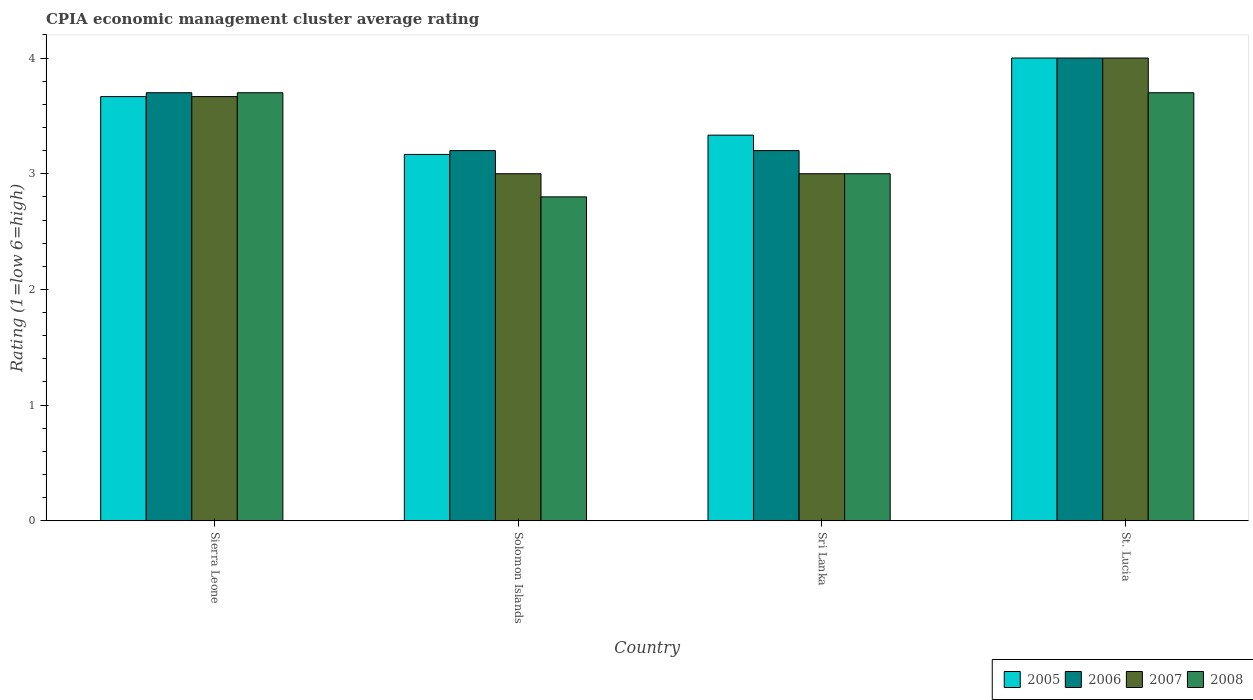How many groups of bars are there?
Your answer should be compact. 4. Are the number of bars on each tick of the X-axis equal?
Offer a terse response. Yes. How many bars are there on the 1st tick from the left?
Offer a very short reply. 4. What is the label of the 1st group of bars from the left?
Keep it short and to the point. Sierra Leone. In how many cases, is the number of bars for a given country not equal to the number of legend labels?
Your response must be concise. 0. What is the CPIA rating in 2005 in Sierra Leone?
Provide a short and direct response. 3.67. Across all countries, what is the minimum CPIA rating in 2006?
Your answer should be compact. 3.2. In which country was the CPIA rating in 2008 maximum?
Provide a succinct answer. Sierra Leone. In which country was the CPIA rating in 2006 minimum?
Keep it short and to the point. Solomon Islands. What is the total CPIA rating in 2007 in the graph?
Offer a very short reply. 13.67. What is the difference between the CPIA rating in 2005 in Solomon Islands and that in St. Lucia?
Your answer should be very brief. -0.83. What is the difference between the CPIA rating in 2007 in Solomon Islands and the CPIA rating in 2008 in Sierra Leone?
Offer a terse response. -0.7. What is the average CPIA rating in 2005 per country?
Your response must be concise. 3.54. In how many countries, is the CPIA rating in 2006 greater than 3.6?
Your answer should be compact. 2. What is the ratio of the CPIA rating in 2008 in Solomon Islands to that in St. Lucia?
Provide a short and direct response. 0.76. Is the CPIA rating in 2006 in Sri Lanka less than that in St. Lucia?
Your response must be concise. Yes. Is the difference between the CPIA rating in 2007 in Solomon Islands and Sri Lanka greater than the difference between the CPIA rating in 2006 in Solomon Islands and Sri Lanka?
Make the answer very short. No. What is the difference between the highest and the second highest CPIA rating in 2006?
Give a very brief answer. -0.5. Is the sum of the CPIA rating in 2008 in Sierra Leone and St. Lucia greater than the maximum CPIA rating in 2005 across all countries?
Make the answer very short. Yes. Is it the case that in every country, the sum of the CPIA rating in 2007 and CPIA rating in 2005 is greater than the sum of CPIA rating in 2006 and CPIA rating in 2008?
Provide a succinct answer. No. What does the 2nd bar from the left in St. Lucia represents?
Keep it short and to the point. 2006. Is it the case that in every country, the sum of the CPIA rating in 2005 and CPIA rating in 2008 is greater than the CPIA rating in 2006?
Ensure brevity in your answer.  Yes. How many bars are there?
Your response must be concise. 16. Are all the bars in the graph horizontal?
Ensure brevity in your answer.  No. How many countries are there in the graph?
Offer a very short reply. 4. Are the values on the major ticks of Y-axis written in scientific E-notation?
Offer a very short reply. No. Does the graph contain any zero values?
Offer a terse response. No. Where does the legend appear in the graph?
Give a very brief answer. Bottom right. How many legend labels are there?
Provide a short and direct response. 4. What is the title of the graph?
Give a very brief answer. CPIA economic management cluster average rating. Does "1991" appear as one of the legend labels in the graph?
Provide a short and direct response. No. What is the label or title of the Y-axis?
Make the answer very short. Rating (1=low 6=high). What is the Rating (1=low 6=high) in 2005 in Sierra Leone?
Your answer should be compact. 3.67. What is the Rating (1=low 6=high) of 2007 in Sierra Leone?
Your response must be concise. 3.67. What is the Rating (1=low 6=high) of 2008 in Sierra Leone?
Make the answer very short. 3.7. What is the Rating (1=low 6=high) in 2005 in Solomon Islands?
Offer a terse response. 3.17. What is the Rating (1=low 6=high) in 2005 in Sri Lanka?
Keep it short and to the point. 3.33. What is the Rating (1=low 6=high) of 2006 in Sri Lanka?
Keep it short and to the point. 3.2. What is the Rating (1=low 6=high) of 2007 in Sri Lanka?
Make the answer very short. 3. What is the Rating (1=low 6=high) in 2008 in Sri Lanka?
Your response must be concise. 3. What is the Rating (1=low 6=high) in 2005 in St. Lucia?
Offer a terse response. 4. What is the Rating (1=low 6=high) of 2006 in St. Lucia?
Offer a very short reply. 4. What is the Rating (1=low 6=high) of 2007 in St. Lucia?
Your answer should be very brief. 4. What is the Rating (1=low 6=high) in 2008 in St. Lucia?
Your answer should be compact. 3.7. Across all countries, what is the maximum Rating (1=low 6=high) in 2005?
Make the answer very short. 4. Across all countries, what is the maximum Rating (1=low 6=high) of 2006?
Keep it short and to the point. 4. Across all countries, what is the maximum Rating (1=low 6=high) of 2007?
Keep it short and to the point. 4. Across all countries, what is the minimum Rating (1=low 6=high) in 2005?
Offer a terse response. 3.17. Across all countries, what is the minimum Rating (1=low 6=high) of 2008?
Offer a very short reply. 2.8. What is the total Rating (1=low 6=high) in 2005 in the graph?
Keep it short and to the point. 14.17. What is the total Rating (1=low 6=high) in 2007 in the graph?
Your response must be concise. 13.67. What is the difference between the Rating (1=low 6=high) of 2005 in Sierra Leone and that in Solomon Islands?
Make the answer very short. 0.5. What is the difference between the Rating (1=low 6=high) of 2006 in Sierra Leone and that in Solomon Islands?
Your response must be concise. 0.5. What is the difference between the Rating (1=low 6=high) in 2007 in Sierra Leone and that in Solomon Islands?
Your response must be concise. 0.67. What is the difference between the Rating (1=low 6=high) in 2008 in Sierra Leone and that in Solomon Islands?
Provide a succinct answer. 0.9. What is the difference between the Rating (1=low 6=high) of 2006 in Sierra Leone and that in Sri Lanka?
Your answer should be compact. 0.5. What is the difference between the Rating (1=low 6=high) in 2008 in Sierra Leone and that in Sri Lanka?
Provide a short and direct response. 0.7. What is the difference between the Rating (1=low 6=high) in 2007 in Sierra Leone and that in St. Lucia?
Offer a very short reply. -0.33. What is the difference between the Rating (1=low 6=high) of 2005 in Solomon Islands and that in Sri Lanka?
Your response must be concise. -0.17. What is the difference between the Rating (1=low 6=high) of 2006 in Solomon Islands and that in Sri Lanka?
Ensure brevity in your answer.  0. What is the difference between the Rating (1=low 6=high) in 2007 in Solomon Islands and that in Sri Lanka?
Give a very brief answer. 0. What is the difference between the Rating (1=low 6=high) in 2008 in Solomon Islands and that in Sri Lanka?
Offer a very short reply. -0.2. What is the difference between the Rating (1=low 6=high) of 2006 in Solomon Islands and that in St. Lucia?
Your answer should be compact. -0.8. What is the difference between the Rating (1=low 6=high) of 2007 in Solomon Islands and that in St. Lucia?
Provide a succinct answer. -1. What is the difference between the Rating (1=low 6=high) in 2008 in Solomon Islands and that in St. Lucia?
Offer a very short reply. -0.9. What is the difference between the Rating (1=low 6=high) in 2005 in Sri Lanka and that in St. Lucia?
Provide a succinct answer. -0.67. What is the difference between the Rating (1=low 6=high) of 2006 in Sri Lanka and that in St. Lucia?
Offer a terse response. -0.8. What is the difference between the Rating (1=low 6=high) of 2007 in Sri Lanka and that in St. Lucia?
Keep it short and to the point. -1. What is the difference between the Rating (1=low 6=high) in 2008 in Sri Lanka and that in St. Lucia?
Offer a terse response. -0.7. What is the difference between the Rating (1=low 6=high) of 2005 in Sierra Leone and the Rating (1=low 6=high) of 2006 in Solomon Islands?
Make the answer very short. 0.47. What is the difference between the Rating (1=low 6=high) of 2005 in Sierra Leone and the Rating (1=low 6=high) of 2008 in Solomon Islands?
Your response must be concise. 0.87. What is the difference between the Rating (1=low 6=high) in 2006 in Sierra Leone and the Rating (1=low 6=high) in 2007 in Solomon Islands?
Provide a short and direct response. 0.7. What is the difference between the Rating (1=low 6=high) in 2006 in Sierra Leone and the Rating (1=low 6=high) in 2008 in Solomon Islands?
Offer a terse response. 0.9. What is the difference between the Rating (1=low 6=high) of 2007 in Sierra Leone and the Rating (1=low 6=high) of 2008 in Solomon Islands?
Your answer should be compact. 0.87. What is the difference between the Rating (1=low 6=high) of 2005 in Sierra Leone and the Rating (1=low 6=high) of 2006 in Sri Lanka?
Provide a short and direct response. 0.47. What is the difference between the Rating (1=low 6=high) in 2005 in Sierra Leone and the Rating (1=low 6=high) in 2007 in Sri Lanka?
Provide a succinct answer. 0.67. What is the difference between the Rating (1=low 6=high) of 2006 in Sierra Leone and the Rating (1=low 6=high) of 2007 in Sri Lanka?
Your answer should be compact. 0.7. What is the difference between the Rating (1=low 6=high) in 2007 in Sierra Leone and the Rating (1=low 6=high) in 2008 in Sri Lanka?
Offer a very short reply. 0.67. What is the difference between the Rating (1=low 6=high) in 2005 in Sierra Leone and the Rating (1=low 6=high) in 2007 in St. Lucia?
Ensure brevity in your answer.  -0.33. What is the difference between the Rating (1=low 6=high) of 2005 in Sierra Leone and the Rating (1=low 6=high) of 2008 in St. Lucia?
Give a very brief answer. -0.03. What is the difference between the Rating (1=low 6=high) of 2006 in Sierra Leone and the Rating (1=low 6=high) of 2008 in St. Lucia?
Give a very brief answer. 0. What is the difference between the Rating (1=low 6=high) in 2007 in Sierra Leone and the Rating (1=low 6=high) in 2008 in St. Lucia?
Keep it short and to the point. -0.03. What is the difference between the Rating (1=low 6=high) of 2005 in Solomon Islands and the Rating (1=low 6=high) of 2006 in Sri Lanka?
Keep it short and to the point. -0.03. What is the difference between the Rating (1=low 6=high) of 2005 in Solomon Islands and the Rating (1=low 6=high) of 2007 in Sri Lanka?
Provide a succinct answer. 0.17. What is the difference between the Rating (1=low 6=high) of 2005 in Solomon Islands and the Rating (1=low 6=high) of 2008 in Sri Lanka?
Your answer should be very brief. 0.17. What is the difference between the Rating (1=low 6=high) in 2007 in Solomon Islands and the Rating (1=low 6=high) in 2008 in Sri Lanka?
Keep it short and to the point. 0. What is the difference between the Rating (1=low 6=high) in 2005 in Solomon Islands and the Rating (1=low 6=high) in 2006 in St. Lucia?
Your answer should be compact. -0.83. What is the difference between the Rating (1=low 6=high) of 2005 in Solomon Islands and the Rating (1=low 6=high) of 2008 in St. Lucia?
Give a very brief answer. -0.53. What is the difference between the Rating (1=low 6=high) in 2007 in Solomon Islands and the Rating (1=low 6=high) in 2008 in St. Lucia?
Give a very brief answer. -0.7. What is the difference between the Rating (1=low 6=high) in 2005 in Sri Lanka and the Rating (1=low 6=high) in 2008 in St. Lucia?
Provide a short and direct response. -0.37. What is the difference between the Rating (1=low 6=high) in 2006 in Sri Lanka and the Rating (1=low 6=high) in 2007 in St. Lucia?
Offer a very short reply. -0.8. What is the difference between the Rating (1=low 6=high) of 2006 in Sri Lanka and the Rating (1=low 6=high) of 2008 in St. Lucia?
Provide a short and direct response. -0.5. What is the average Rating (1=low 6=high) of 2005 per country?
Make the answer very short. 3.54. What is the average Rating (1=low 6=high) in 2006 per country?
Provide a succinct answer. 3.52. What is the average Rating (1=low 6=high) of 2007 per country?
Provide a succinct answer. 3.42. What is the average Rating (1=low 6=high) in 2008 per country?
Keep it short and to the point. 3.3. What is the difference between the Rating (1=low 6=high) of 2005 and Rating (1=low 6=high) of 2006 in Sierra Leone?
Offer a terse response. -0.03. What is the difference between the Rating (1=low 6=high) in 2005 and Rating (1=low 6=high) in 2007 in Sierra Leone?
Offer a terse response. 0. What is the difference between the Rating (1=low 6=high) in 2005 and Rating (1=low 6=high) in 2008 in Sierra Leone?
Your response must be concise. -0.03. What is the difference between the Rating (1=low 6=high) in 2006 and Rating (1=low 6=high) in 2007 in Sierra Leone?
Your answer should be very brief. 0.03. What is the difference between the Rating (1=low 6=high) of 2007 and Rating (1=low 6=high) of 2008 in Sierra Leone?
Offer a very short reply. -0.03. What is the difference between the Rating (1=low 6=high) in 2005 and Rating (1=low 6=high) in 2006 in Solomon Islands?
Ensure brevity in your answer.  -0.03. What is the difference between the Rating (1=low 6=high) in 2005 and Rating (1=low 6=high) in 2007 in Solomon Islands?
Ensure brevity in your answer.  0.17. What is the difference between the Rating (1=low 6=high) in 2005 and Rating (1=low 6=high) in 2008 in Solomon Islands?
Your answer should be very brief. 0.37. What is the difference between the Rating (1=low 6=high) of 2006 and Rating (1=low 6=high) of 2008 in Solomon Islands?
Keep it short and to the point. 0.4. What is the difference between the Rating (1=low 6=high) in 2007 and Rating (1=low 6=high) in 2008 in Solomon Islands?
Your answer should be very brief. 0.2. What is the difference between the Rating (1=low 6=high) in 2005 and Rating (1=low 6=high) in 2006 in Sri Lanka?
Provide a short and direct response. 0.13. What is the difference between the Rating (1=low 6=high) in 2005 and Rating (1=low 6=high) in 2008 in Sri Lanka?
Your answer should be compact. 0.33. What is the difference between the Rating (1=low 6=high) in 2006 and Rating (1=low 6=high) in 2007 in Sri Lanka?
Keep it short and to the point. 0.2. What is the difference between the Rating (1=low 6=high) in 2007 and Rating (1=low 6=high) in 2008 in Sri Lanka?
Make the answer very short. 0. What is the difference between the Rating (1=low 6=high) in 2006 and Rating (1=low 6=high) in 2008 in St. Lucia?
Ensure brevity in your answer.  0.3. What is the ratio of the Rating (1=low 6=high) in 2005 in Sierra Leone to that in Solomon Islands?
Your response must be concise. 1.16. What is the ratio of the Rating (1=low 6=high) in 2006 in Sierra Leone to that in Solomon Islands?
Give a very brief answer. 1.16. What is the ratio of the Rating (1=low 6=high) in 2007 in Sierra Leone to that in Solomon Islands?
Your response must be concise. 1.22. What is the ratio of the Rating (1=low 6=high) in 2008 in Sierra Leone to that in Solomon Islands?
Keep it short and to the point. 1.32. What is the ratio of the Rating (1=low 6=high) of 2006 in Sierra Leone to that in Sri Lanka?
Make the answer very short. 1.16. What is the ratio of the Rating (1=low 6=high) of 2007 in Sierra Leone to that in Sri Lanka?
Ensure brevity in your answer.  1.22. What is the ratio of the Rating (1=low 6=high) in 2008 in Sierra Leone to that in Sri Lanka?
Your answer should be compact. 1.23. What is the ratio of the Rating (1=low 6=high) of 2005 in Sierra Leone to that in St. Lucia?
Keep it short and to the point. 0.92. What is the ratio of the Rating (1=low 6=high) of 2006 in Sierra Leone to that in St. Lucia?
Provide a succinct answer. 0.93. What is the ratio of the Rating (1=low 6=high) in 2007 in Sierra Leone to that in St. Lucia?
Ensure brevity in your answer.  0.92. What is the ratio of the Rating (1=low 6=high) in 2006 in Solomon Islands to that in Sri Lanka?
Give a very brief answer. 1. What is the ratio of the Rating (1=low 6=high) of 2007 in Solomon Islands to that in Sri Lanka?
Keep it short and to the point. 1. What is the ratio of the Rating (1=low 6=high) in 2008 in Solomon Islands to that in Sri Lanka?
Ensure brevity in your answer.  0.93. What is the ratio of the Rating (1=low 6=high) of 2005 in Solomon Islands to that in St. Lucia?
Offer a very short reply. 0.79. What is the ratio of the Rating (1=low 6=high) in 2006 in Solomon Islands to that in St. Lucia?
Ensure brevity in your answer.  0.8. What is the ratio of the Rating (1=low 6=high) of 2008 in Solomon Islands to that in St. Lucia?
Your response must be concise. 0.76. What is the ratio of the Rating (1=low 6=high) in 2005 in Sri Lanka to that in St. Lucia?
Offer a terse response. 0.83. What is the ratio of the Rating (1=low 6=high) in 2007 in Sri Lanka to that in St. Lucia?
Offer a very short reply. 0.75. What is the ratio of the Rating (1=low 6=high) in 2008 in Sri Lanka to that in St. Lucia?
Keep it short and to the point. 0.81. What is the difference between the highest and the second highest Rating (1=low 6=high) in 2008?
Offer a very short reply. 0. What is the difference between the highest and the lowest Rating (1=low 6=high) of 2005?
Your answer should be compact. 0.83. What is the difference between the highest and the lowest Rating (1=low 6=high) in 2006?
Your response must be concise. 0.8. 